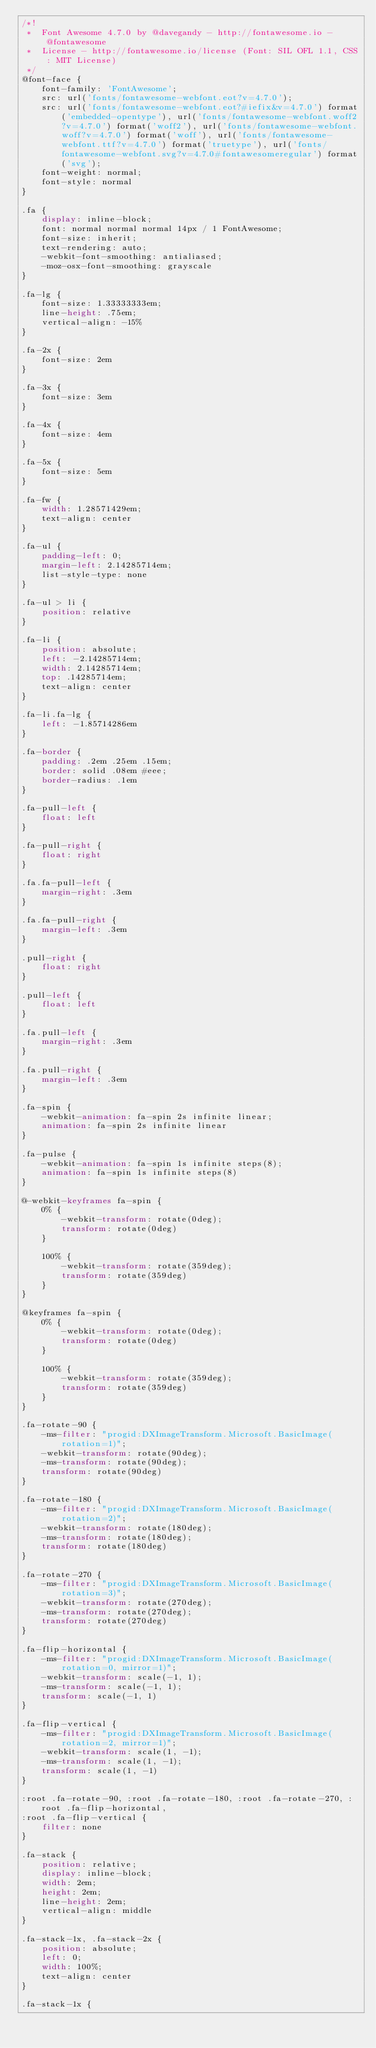<code> <loc_0><loc_0><loc_500><loc_500><_CSS_>/*!
 *  Font Awesome 4.7.0 by @davegandy - http://fontawesome.io - @fontawesome
 *  License - http://fontawesome.io/license (Font: SIL OFL 1.1, CSS: MIT License)
 */
@font-face {
    font-family: 'FontAwesome';
    src: url('fonts/fontawesome-webfont.eot?v=4.7.0');
    src: url('fonts/fontawesome-webfont.eot?#iefix&v=4.7.0') format('embedded-opentype'), url('fonts/fontawesome-webfont.woff2?v=4.7.0') format('woff2'), url('fonts/fontawesome-webfont.woff?v=4.7.0') format('woff'), url('fonts/fontawesome-webfont.ttf?v=4.7.0') format('truetype'), url('fonts/fontawesome-webfont.svg?v=4.7.0#fontawesomeregular') format('svg');
    font-weight: normal;
    font-style: normal
}

.fa {
    display: inline-block;
    font: normal normal normal 14px / 1 FontAwesome;
    font-size: inherit;
    text-rendering: auto;
    -webkit-font-smoothing: antialiased;
    -moz-osx-font-smoothing: grayscale
}

.fa-lg {
    font-size: 1.33333333em;
    line-height: .75em;
    vertical-align: -15%
}

.fa-2x {
    font-size: 2em
}

.fa-3x {
    font-size: 3em
}

.fa-4x {
    font-size: 4em
}

.fa-5x {
    font-size: 5em
}

.fa-fw {
    width: 1.28571429em;
    text-align: center
}

.fa-ul {
    padding-left: 0;
    margin-left: 2.14285714em;
    list-style-type: none
}

.fa-ul > li {
    position: relative
}

.fa-li {
    position: absolute;
    left: -2.14285714em;
    width: 2.14285714em;
    top: .14285714em;
    text-align: center
}

.fa-li.fa-lg {
    left: -1.85714286em
}

.fa-border {
    padding: .2em .25em .15em;
    border: solid .08em #eee;
    border-radius: .1em
}

.fa-pull-left {
    float: left
}

.fa-pull-right {
    float: right
}

.fa.fa-pull-left {
    margin-right: .3em
}

.fa.fa-pull-right {
    margin-left: .3em
}

.pull-right {
    float: right
}

.pull-left {
    float: left
}

.fa.pull-left {
    margin-right: .3em
}

.fa.pull-right {
    margin-left: .3em
}

.fa-spin {
    -webkit-animation: fa-spin 2s infinite linear;
    animation: fa-spin 2s infinite linear
}

.fa-pulse {
    -webkit-animation: fa-spin 1s infinite steps(8);
    animation: fa-spin 1s infinite steps(8)
}

@-webkit-keyframes fa-spin {
    0% {
        -webkit-transform: rotate(0deg);
        transform: rotate(0deg)
    }

    100% {
        -webkit-transform: rotate(359deg);
        transform: rotate(359deg)
    }
}

@keyframes fa-spin {
    0% {
        -webkit-transform: rotate(0deg);
        transform: rotate(0deg)
    }

    100% {
        -webkit-transform: rotate(359deg);
        transform: rotate(359deg)
    }
}

.fa-rotate-90 {
    -ms-filter: "progid:DXImageTransform.Microsoft.BasicImage(rotation=1)";
    -webkit-transform: rotate(90deg);
    -ms-transform: rotate(90deg);
    transform: rotate(90deg)
}

.fa-rotate-180 {
    -ms-filter: "progid:DXImageTransform.Microsoft.BasicImage(rotation=2)";
    -webkit-transform: rotate(180deg);
    -ms-transform: rotate(180deg);
    transform: rotate(180deg)
}

.fa-rotate-270 {
    -ms-filter: "progid:DXImageTransform.Microsoft.BasicImage(rotation=3)";
    -webkit-transform: rotate(270deg);
    -ms-transform: rotate(270deg);
    transform: rotate(270deg)
}

.fa-flip-horizontal {
    -ms-filter: "progid:DXImageTransform.Microsoft.BasicImage(rotation=0, mirror=1)";
    -webkit-transform: scale(-1, 1);
    -ms-transform: scale(-1, 1);
    transform: scale(-1, 1)
}

.fa-flip-vertical {
    -ms-filter: "progid:DXImageTransform.Microsoft.BasicImage(rotation=2, mirror=1)";
    -webkit-transform: scale(1, -1);
    -ms-transform: scale(1, -1);
    transform: scale(1, -1)
}

:root .fa-rotate-90, :root .fa-rotate-180, :root .fa-rotate-270, :root .fa-flip-horizontal,
:root .fa-flip-vertical {
    filter: none
}

.fa-stack {
    position: relative;
    display: inline-block;
    width: 2em;
    height: 2em;
    line-height: 2em;
    vertical-align: middle
}

.fa-stack-1x, .fa-stack-2x {
    position: absolute;
    left: 0;
    width: 100%;
    text-align: center
}

.fa-stack-1x {</code> 